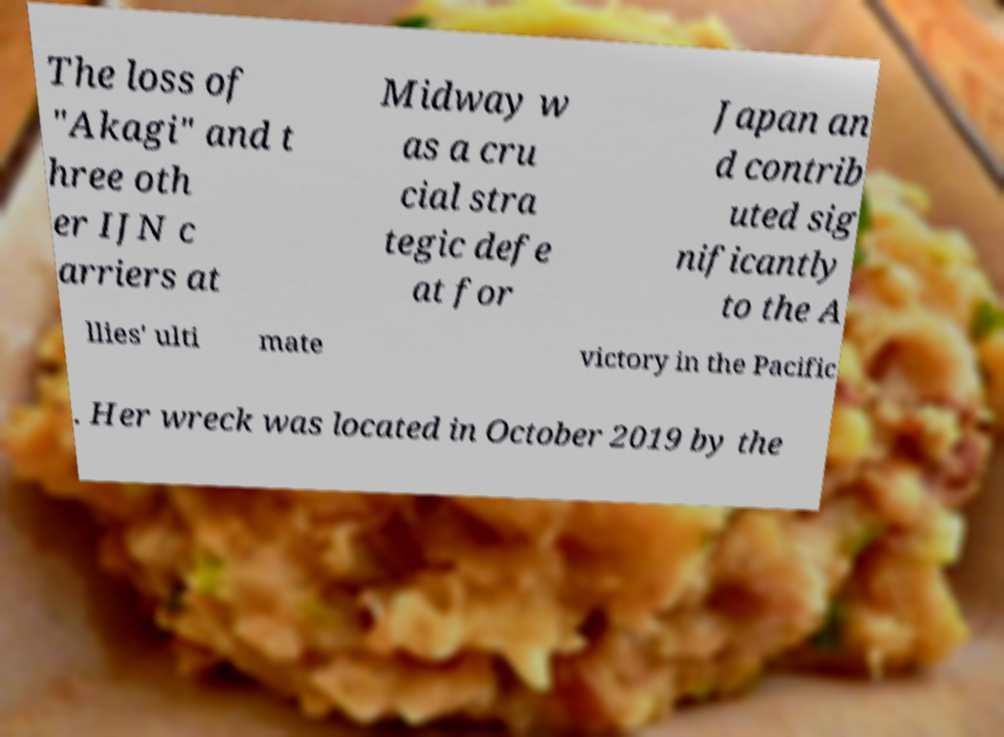There's text embedded in this image that I need extracted. Can you transcribe it verbatim? The loss of "Akagi" and t hree oth er IJN c arriers at Midway w as a cru cial stra tegic defe at for Japan an d contrib uted sig nificantly to the A llies' ulti mate victory in the Pacific . Her wreck was located in October 2019 by the 